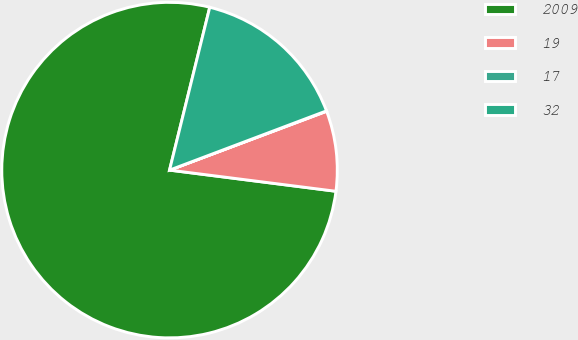Convert chart. <chart><loc_0><loc_0><loc_500><loc_500><pie_chart><fcel>2009<fcel>19<fcel>17<fcel>32<nl><fcel>76.84%<fcel>7.72%<fcel>0.04%<fcel>15.4%<nl></chart> 